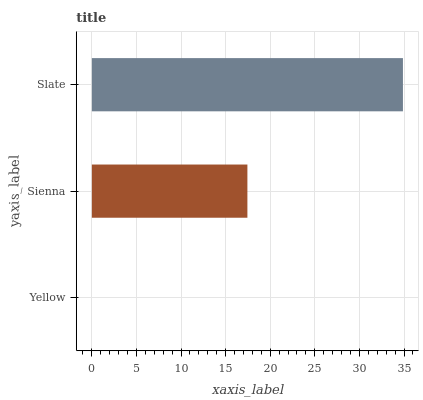Is Yellow the minimum?
Answer yes or no. Yes. Is Slate the maximum?
Answer yes or no. Yes. Is Sienna the minimum?
Answer yes or no. No. Is Sienna the maximum?
Answer yes or no. No. Is Sienna greater than Yellow?
Answer yes or no. Yes. Is Yellow less than Sienna?
Answer yes or no. Yes. Is Yellow greater than Sienna?
Answer yes or no. No. Is Sienna less than Yellow?
Answer yes or no. No. Is Sienna the high median?
Answer yes or no. Yes. Is Sienna the low median?
Answer yes or no. Yes. Is Slate the high median?
Answer yes or no. No. Is Slate the low median?
Answer yes or no. No. 